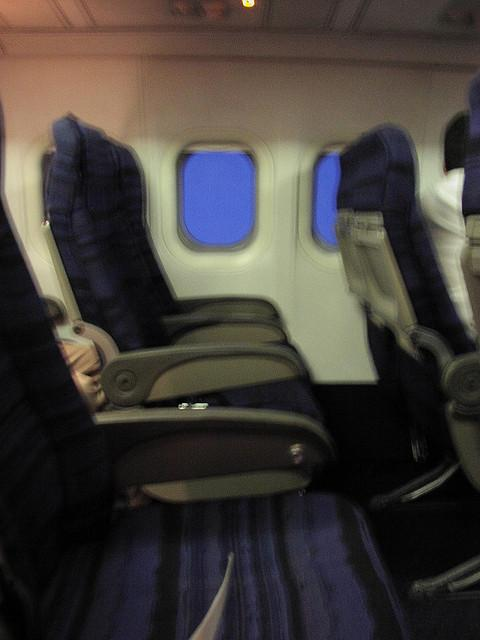Where are the seats placed inside?

Choices:
A) subway
B) sedan
C) van
D) airplane airplane 